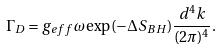Convert formula to latex. <formula><loc_0><loc_0><loc_500><loc_500>\Gamma _ { D } = g _ { e f f } \omega \exp ( - \Delta S _ { B H } ) \frac { d ^ { 4 } k } { ( 2 \pi ) ^ { 4 } } .</formula> 